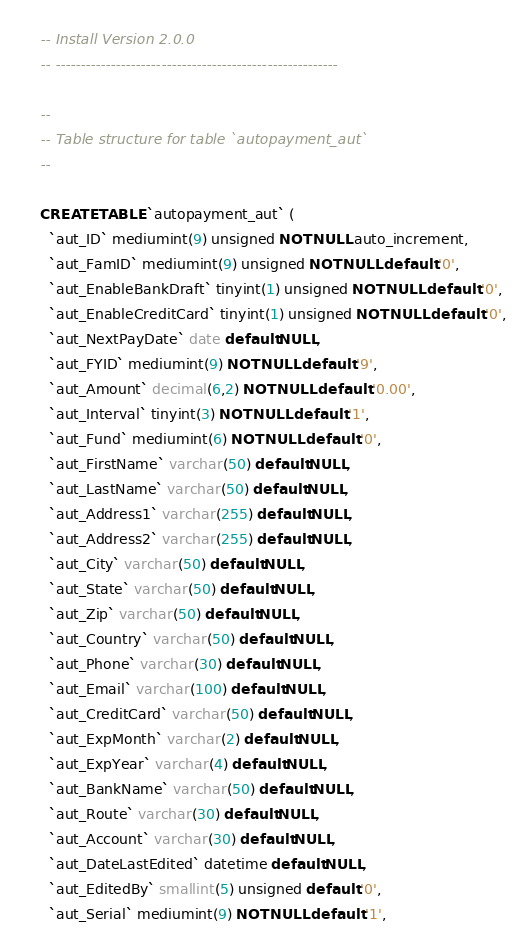Convert code to text. <code><loc_0><loc_0><loc_500><loc_500><_SQL_>-- Install Version 2.0.0
-- --------------------------------------------------------

--
-- Table structure for table `autopayment_aut`
--

CREATE TABLE `autopayment_aut` (
  `aut_ID` mediumint(9) unsigned NOT NULL auto_increment,
  `aut_FamID` mediumint(9) unsigned NOT NULL default '0',
  `aut_EnableBankDraft` tinyint(1) unsigned NOT NULL default '0',
  `aut_EnableCreditCard` tinyint(1) unsigned NOT NULL default '0',
  `aut_NextPayDate` date default NULL,
  `aut_FYID` mediumint(9) NOT NULL default '9',
  `aut_Amount` decimal(6,2) NOT NULL default '0.00',
  `aut_Interval` tinyint(3) NOT NULL default '1',
  `aut_Fund` mediumint(6) NOT NULL default '0',
  `aut_FirstName` varchar(50) default NULL,
  `aut_LastName` varchar(50) default NULL,
  `aut_Address1` varchar(255) default NULL,
  `aut_Address2` varchar(255) default NULL,
  `aut_City` varchar(50) default NULL,
  `aut_State` varchar(50) default NULL,
  `aut_Zip` varchar(50) default NULL,
  `aut_Country` varchar(50) default NULL,
  `aut_Phone` varchar(30) default NULL,
  `aut_Email` varchar(100) default NULL,
  `aut_CreditCard` varchar(50) default NULL,
  `aut_ExpMonth` varchar(2) default NULL,
  `aut_ExpYear` varchar(4) default NULL,
  `aut_BankName` varchar(50) default NULL,
  `aut_Route` varchar(30) default NULL,
  `aut_Account` varchar(30) default NULL,
  `aut_DateLastEdited` datetime default NULL,
  `aut_EditedBy` smallint(5) unsigned default '0',
  `aut_Serial` mediumint(9) NOT NULL default '1',</code> 